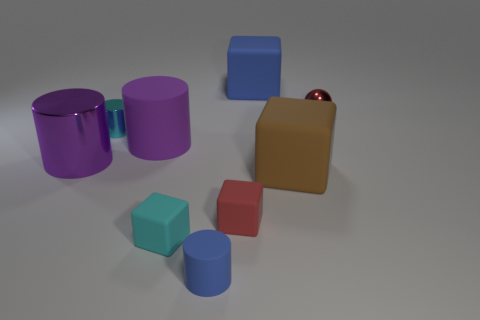There is a cube to the left of the red object left of the tiny metal sphere; is there a red object to the left of it? no 